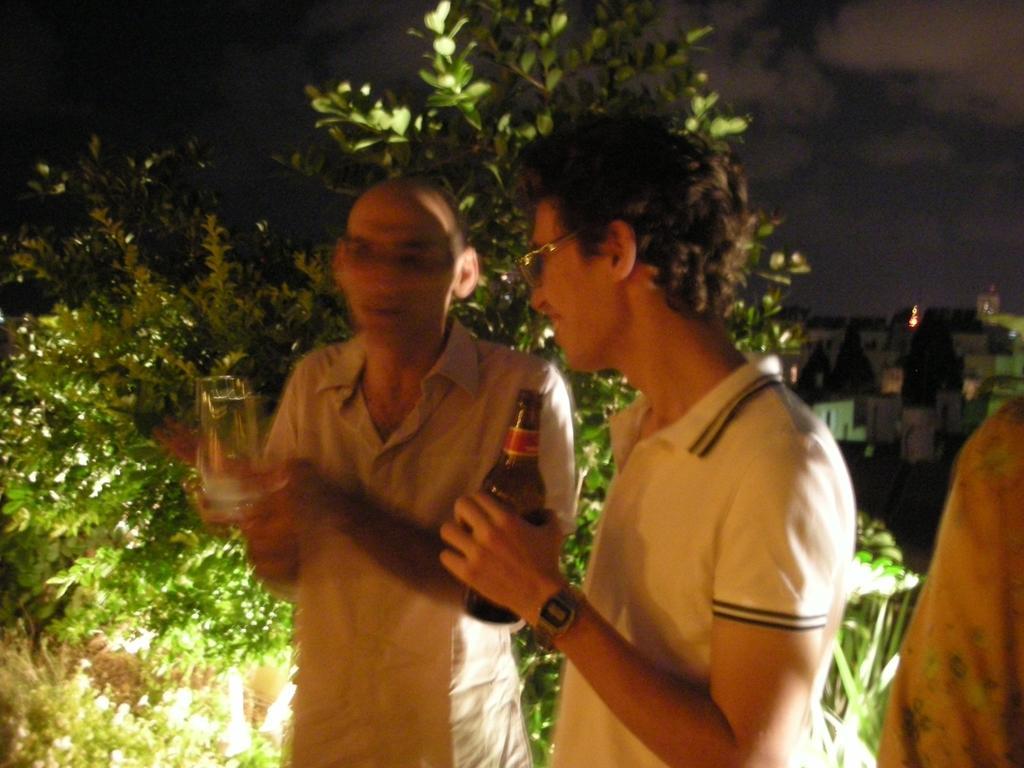Could you give a brief overview of what you see in this image? In this image In the middle there is a man he is holding a glass he wears shirt. On the right there are two people on that In the middle there is a man he wears t shirt and watch he is holding a bottle. In the background there are many trees, building, sky and cloud. 